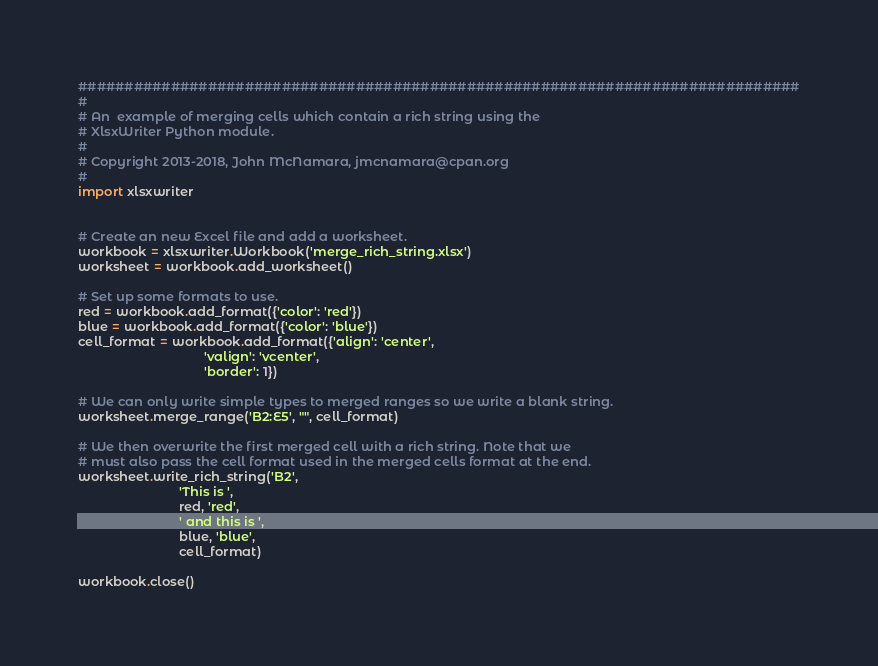Convert code to text. <code><loc_0><loc_0><loc_500><loc_500><_Python_>##############################################################################
#
# An  example of merging cells which contain a rich string using the
# XlsxWriter Python module.
#
# Copyright 2013-2018, John McNamara, jmcnamara@cpan.org
#
import xlsxwriter


# Create an new Excel file and add a worksheet.
workbook = xlsxwriter.Workbook('merge_rich_string.xlsx')
worksheet = workbook.add_worksheet()

# Set up some formats to use.
red = workbook.add_format({'color': 'red'})
blue = workbook.add_format({'color': 'blue'})
cell_format = workbook.add_format({'align': 'center',
                                   'valign': 'vcenter',
                                   'border': 1})

# We can only write simple types to merged ranges so we write a blank string.
worksheet.merge_range('B2:E5', "", cell_format)

# We then overwrite the first merged cell with a rich string. Note that we
# must also pass the cell format used in the merged cells format at the end.
worksheet.write_rich_string('B2',
                            'This is ',
                            red, 'red',
                            ' and this is ',
                            blue, 'blue',
                            cell_format)

workbook.close()
</code> 